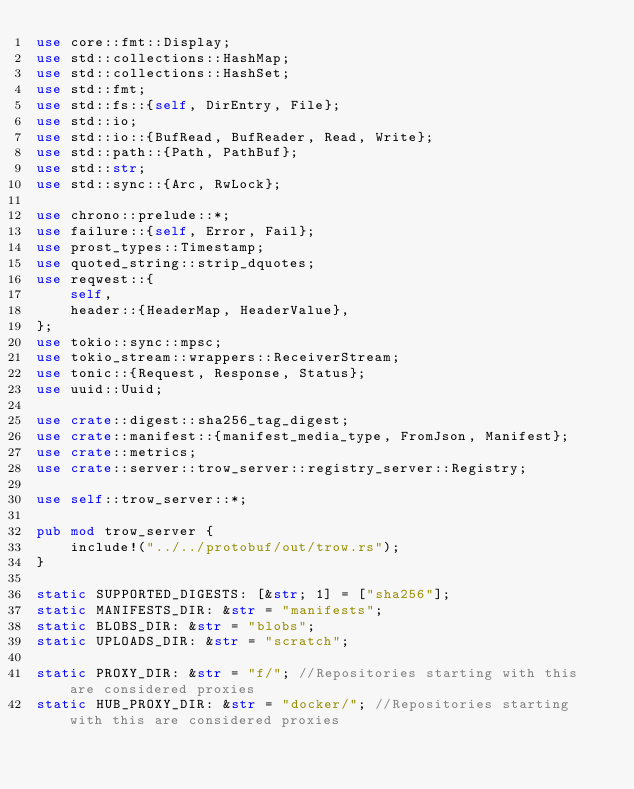<code> <loc_0><loc_0><loc_500><loc_500><_Rust_>use core::fmt::Display;
use std::collections::HashMap;
use std::collections::HashSet;
use std::fmt;
use std::fs::{self, DirEntry, File};
use std::io;
use std::io::{BufRead, BufReader, Read, Write};
use std::path::{Path, PathBuf};
use std::str;
use std::sync::{Arc, RwLock};

use chrono::prelude::*;
use failure::{self, Error, Fail};
use prost_types::Timestamp;
use quoted_string::strip_dquotes;
use reqwest::{
    self,
    header::{HeaderMap, HeaderValue},
};
use tokio::sync::mpsc;
use tokio_stream::wrappers::ReceiverStream;
use tonic::{Request, Response, Status};
use uuid::Uuid;

use crate::digest::sha256_tag_digest;
use crate::manifest::{manifest_media_type, FromJson, Manifest};
use crate::metrics;
use crate::server::trow_server::registry_server::Registry;

use self::trow_server::*;

pub mod trow_server {
    include!("../../protobuf/out/trow.rs");
}

static SUPPORTED_DIGESTS: [&str; 1] = ["sha256"];
static MANIFESTS_DIR: &str = "manifests";
static BLOBS_DIR: &str = "blobs";
static UPLOADS_DIR: &str = "scratch";

static PROXY_DIR: &str = "f/"; //Repositories starting with this are considered proxies
static HUB_PROXY_DIR: &str = "docker/"; //Repositories starting with this are considered proxies</code> 